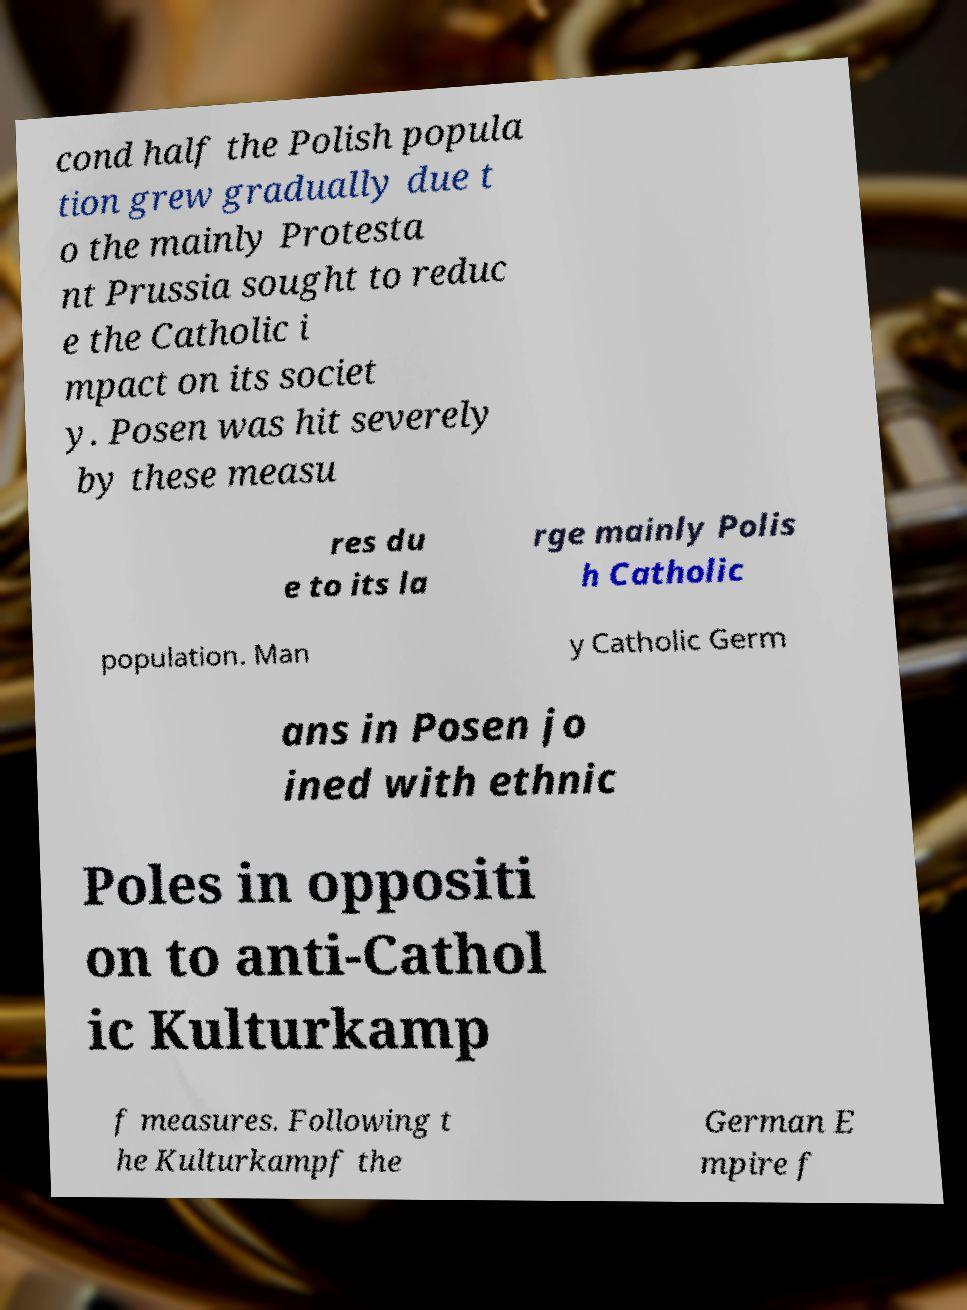There's text embedded in this image that I need extracted. Can you transcribe it verbatim? cond half the Polish popula tion grew gradually due t o the mainly Protesta nt Prussia sought to reduc e the Catholic i mpact on its societ y. Posen was hit severely by these measu res du e to its la rge mainly Polis h Catholic population. Man y Catholic Germ ans in Posen jo ined with ethnic Poles in oppositi on to anti-Cathol ic Kulturkamp f measures. Following t he Kulturkampf the German E mpire f 